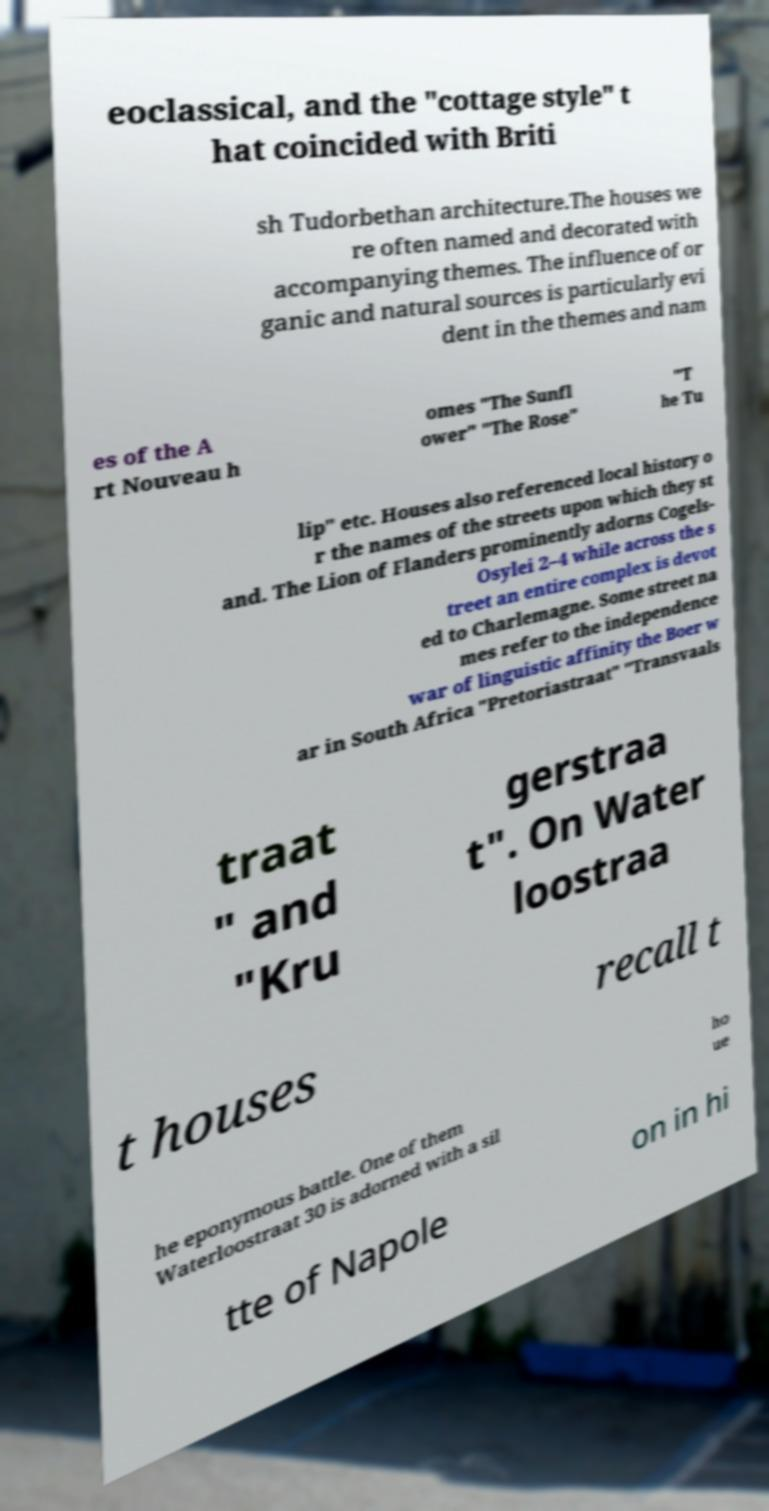I need the written content from this picture converted into text. Can you do that? eoclassical, and the "cottage style" t hat coincided with Briti sh Tudorbethan architecture.The houses we re often named and decorated with accompanying themes. The influence of or ganic and natural sources is particularly evi dent in the themes and nam es of the A rt Nouveau h omes "The Sunfl ower" "The Rose" "T he Tu lip" etc. Houses also referenced local history o r the names of the streets upon which they st and. The Lion of Flanders prominently adorns Cogels- Osylei 2–4 while across the s treet an entire complex is devot ed to Charlemagne. Some street na mes refer to the independence war of linguistic affinity the Boer w ar in South Africa "Pretoriastraat" "Transvaals traat " and "Kru gerstraa t". On Water loostraa t houses recall t he eponymous battle. One of them Waterloostraat 30 is adorned with a sil ho ue tte of Napole on in hi 